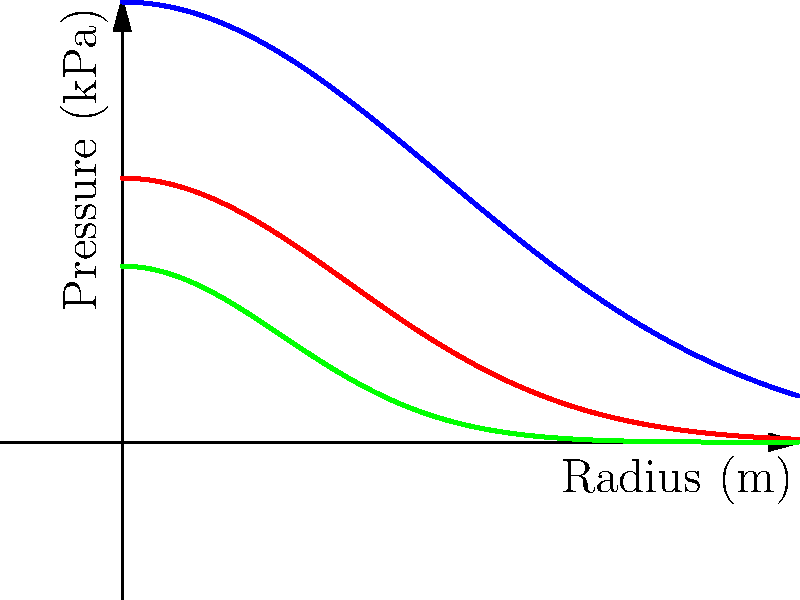Consider the graph showing plasma pressure profiles for different density regimes in a tokamak. If the pressure profile for the high-density case is given by $p(r) = 5e^{-r^2/4}$ kPa, where $r$ is the radius in meters, calculate $\frac{dp}{dr}$ at $r = 1$ m. How does this gradient compare to the gradients of the medium and low-density profiles at the same radius? To solve this problem, we'll follow these steps:

1) The pressure profile for the high-density case is given by:
   $p(r) = 5e^{-r^2/4}$ kPa

2) To find $\frac{dp}{dr}$, we need to differentiate $p(r)$ with respect to $r$:
   $\frac{dp}{dr} = 5 \cdot \frac{d}{dr}(e^{-r^2/4})$
   $= 5 \cdot e^{-r^2/4} \cdot \frac{d}{dr}(-r^2/4)$
   $= 5 \cdot e^{-r^2/4} \cdot (-r/2)$
   $= -\frac{5r}{2}e^{-r^2/4}$ kPa/m

3) Now, we evaluate this at $r = 1$ m:
   $\frac{dp}{dr}|_{r=1} = -\frac{5}{2}e^{-1/4}$ kPa/m
   $\approx -2.19$ kPa/m

4) For the medium-density profile, we can infer from the graph that $p(r) = 3e^{-r^2/2}$ kPa.
   Following the same process:
   $\frac{dp}{dr} = -3re^{-r^2/2}$ kPa/m
   At $r = 1$ m: $\frac{dp}{dr}|_{r=1} = -3e^{-1/2} \approx -1.82$ kPa/m

5) For the low-density profile, $p(r) = 2e^{-r^2}$ kPa.
   $\frac{dp}{dr} = -4re^{-r^2}$ kPa/m
   At $r = 1$ m: $\frac{dp}{dr}|_{r=1} = -4e^{-1} \approx -1.47$ kPa/m

6) Comparing the gradients at $r = 1$ m:
   High density: -2.19 kPa/m
   Medium density: -1.82 kPa/m
   Low density: -1.47 kPa/m

The high-density profile has the steepest gradient, followed by the medium-density profile, and then the low-density profile. This matches what we observe in the graph, where the high-density curve decreases most rapidly with radius.
Answer: $\frac{dp}{dr}|_{r=1} = -\frac{5}{2}e^{-1/4} \approx -2.19$ kPa/m; steepest gradient compared to medium and low-density profiles. 